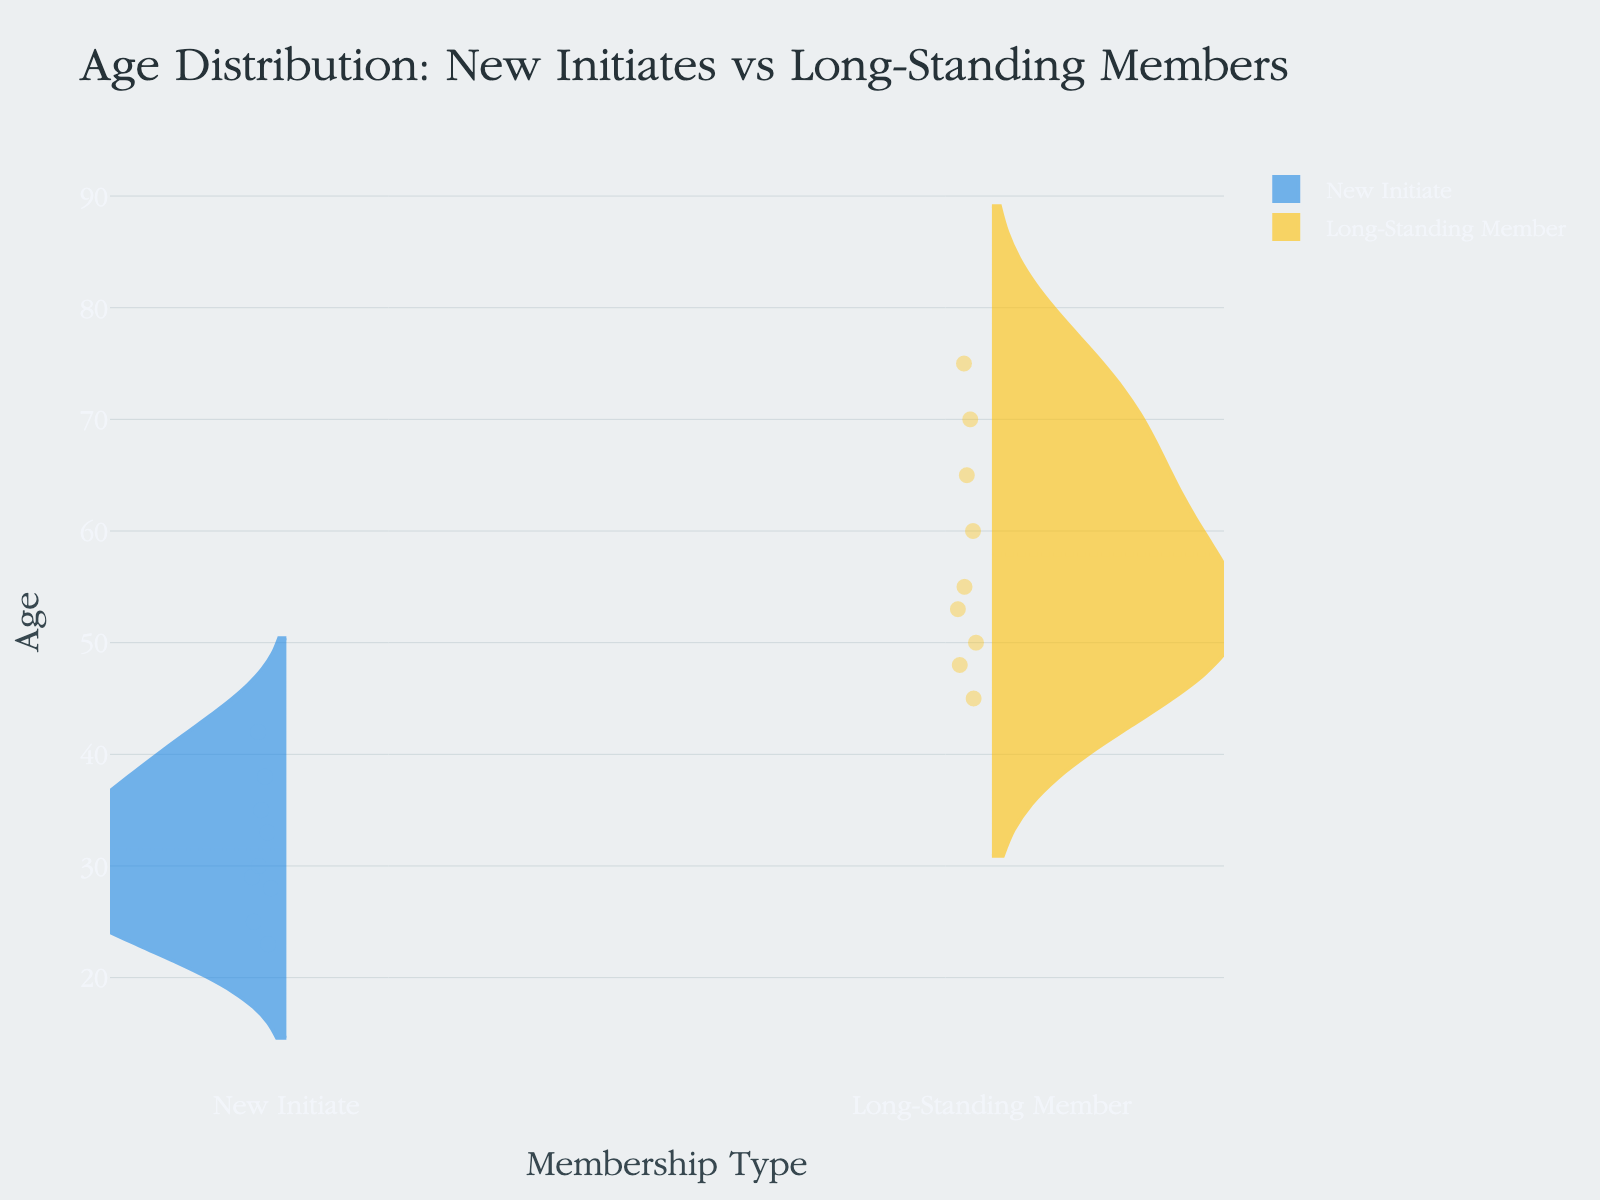what is the main title of the chart? The main title is located at the top of the chart and typically summarizes the primary information presented. Here, it helps viewers immediately understand what the chart represents.
Answer: Age Distribution: New Initiates vs Long-Standing Members How many age data points are there for new initiates? Each individual point on the negative (left) side of the violin plot represents an age data point for new initiates. By counting these points, one can determine the quantity.
Answer: 9 What is the highest age recorded for long-standing members? The highest age is the topmost point on the positive (right) side of the violin plot for long-standing members. This point denotes the oldest age in that group.
Answer: 75 What is the median age for new initiates? The median value is indicated by a horizontal line within the violin plot. The location of this line on the y-axis will tell us the median age for new initiates.
Answer: 30 Which membership type has a wider spread of ages? A wider spread is indicated by the extent of the violin plot along the y-axis. By examining the distribution widths from top to bottom for both membership types, we can determine which has the broader age range.
Answer: Long-Standing Members Do long-standing members generally have higher ages than new initiates? Comparing the central tendency and overall spread (both top and bottom extremes) of each violin plot reveals that long-standing members generally have higher ages than new initiates.
Answer: Yes What's the average age difference between the new initiates and the long-standing members? To find this, calculate the average age for both groups and subtract the new initiates' average from the long-standing members' average. The average age for new initiates can be calculated by summing their ages and dividing by the number of new initiates; the same applies to long-standing members.
Answer: The average difference Is the age distribution for new initiates skewed or symmetrical? By looking at the shape of the violin plot for new initiates, one can determine if it is symmetrical (evenly distributed on either side of the mean) or skewed (most data is clustered at one end).
Answer: Symmetrical Which group has a closer mean and median age? The mean value can be estimated based on the symmetry and density of the violin plot, while the median is the horizontal line within each plot. By comparing how close these two values are for both groups, we can determine which has a closer mean and median age.
Answer: New Initiates 